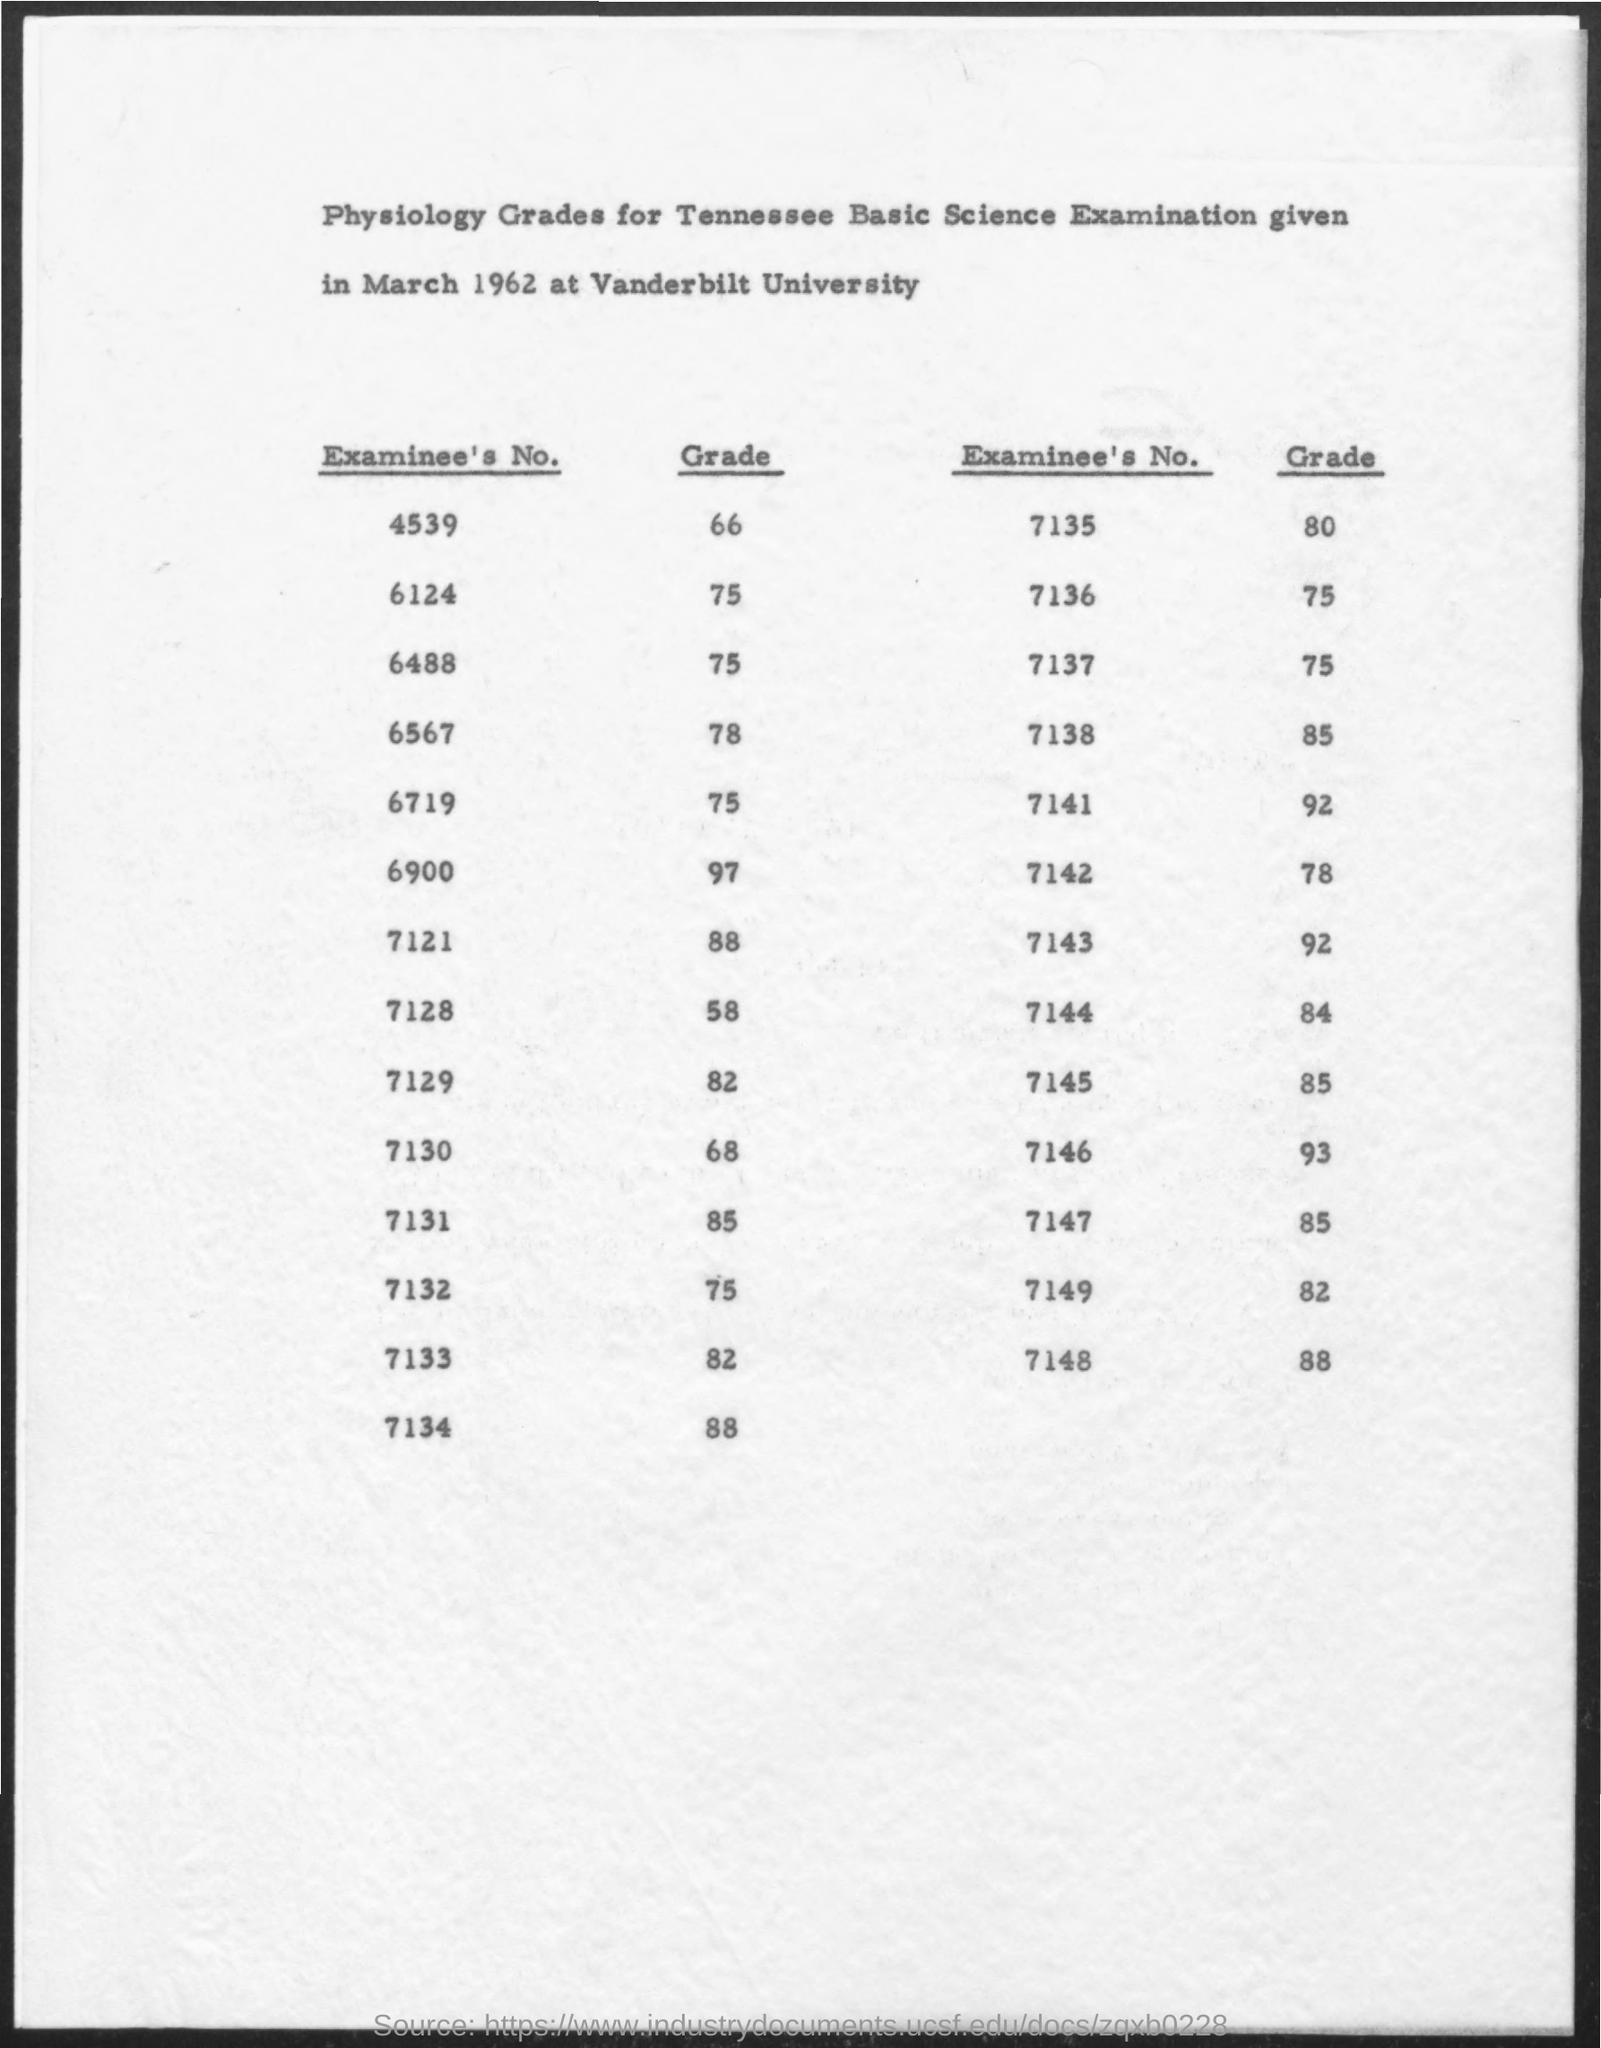Draw attention to some important aspects in this diagram. The examinee's answer to question number 7141 is 92%. The examinee's number 6567 received a grade of 78 out of 100. The examinee's answer to question number 7121 is 88. Vanderbilt University is a university mentioned in the given form. The examinee's number 6124 received a grade of 75. 